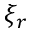<formula> <loc_0><loc_0><loc_500><loc_500>\xi _ { r }</formula> 